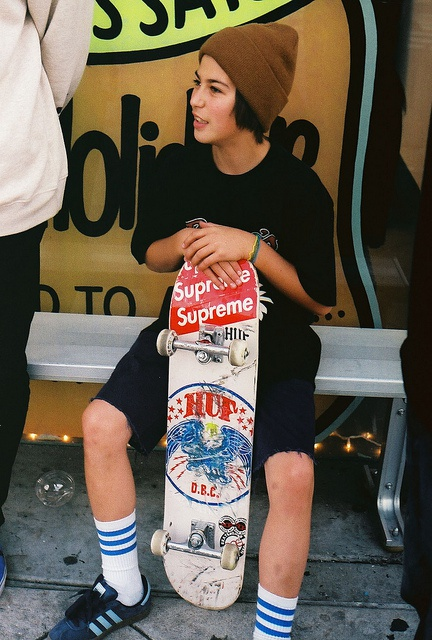Describe the objects in this image and their specific colors. I can see people in lightgray, black, salmon, and tan tones, skateboard in lightgray, darkgray, salmon, and pink tones, people in lightgray, black, and tan tones, and bench in lightgray, darkgray, black, gray, and blue tones in this image. 